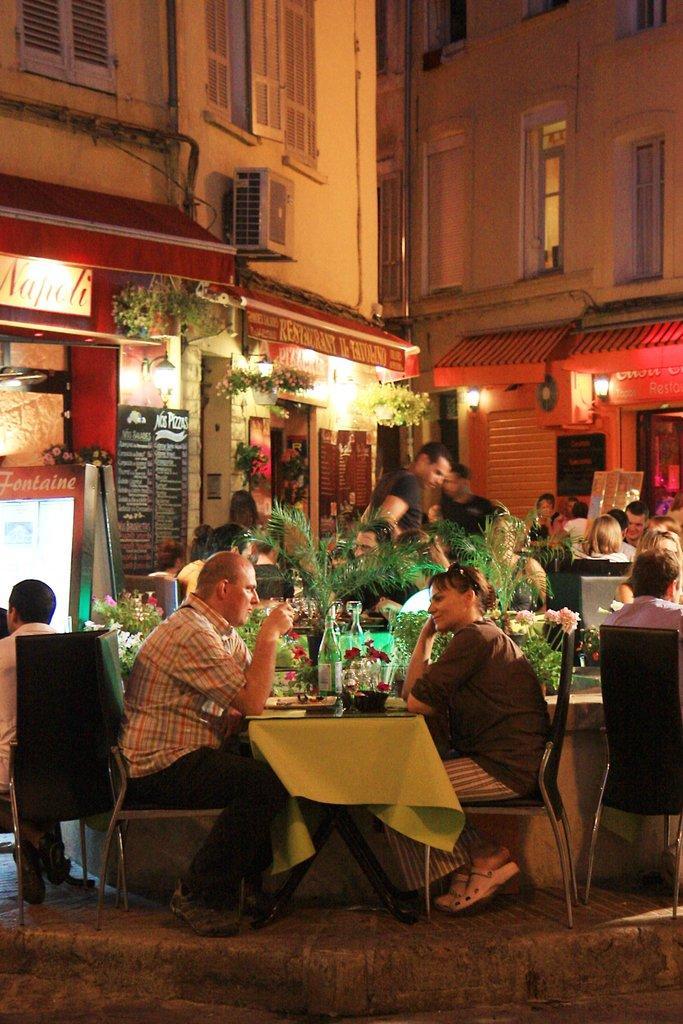In one or two sentences, can you explain what this image depicts? In this picture we can see a group of people sitting on chairs and in front of them on table we have bottles, flowers, papers and some are standing and in the background we can see buildings with windows, pipe , sun shade, banners. 